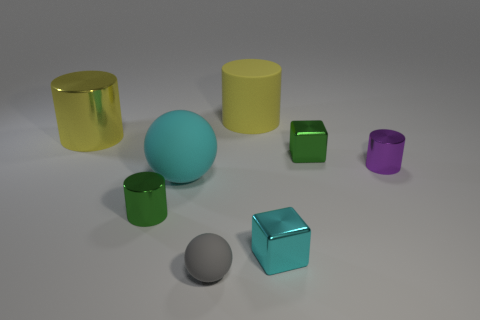Add 1 cylinders. How many objects exist? 9 Subtract all spheres. How many objects are left? 6 Add 7 small gray rubber spheres. How many small gray rubber spheres exist? 8 Subtract 1 yellow cylinders. How many objects are left? 7 Subtract all tiny green blocks. Subtract all large yellow rubber cylinders. How many objects are left? 6 Add 2 green cylinders. How many green cylinders are left? 3 